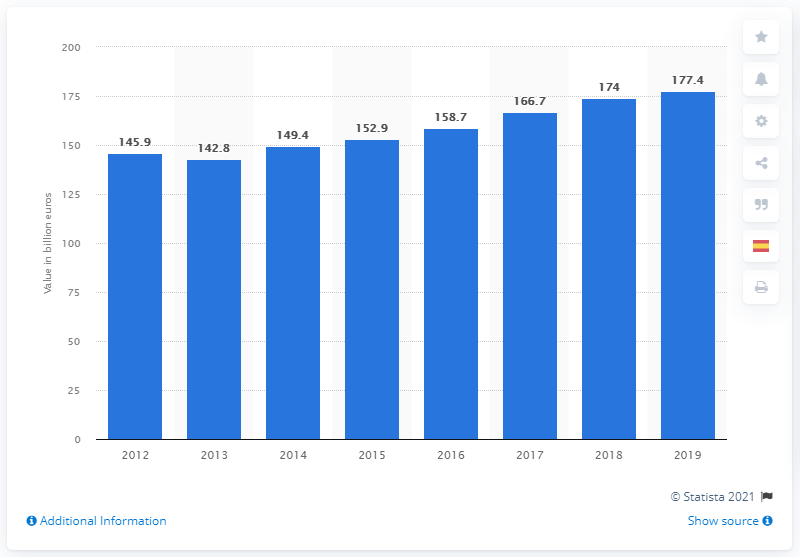What insights can you provide about the trend shown in this chart? The bar chart illustrates a general upward trend in Spain's GDP from the year 2012 to 2019, with a small dip between 2012 and 2013. This may suggest that the country's economic policies and market conditions have favored growth during this period, alongside a recovery from any previous economic hardships. 